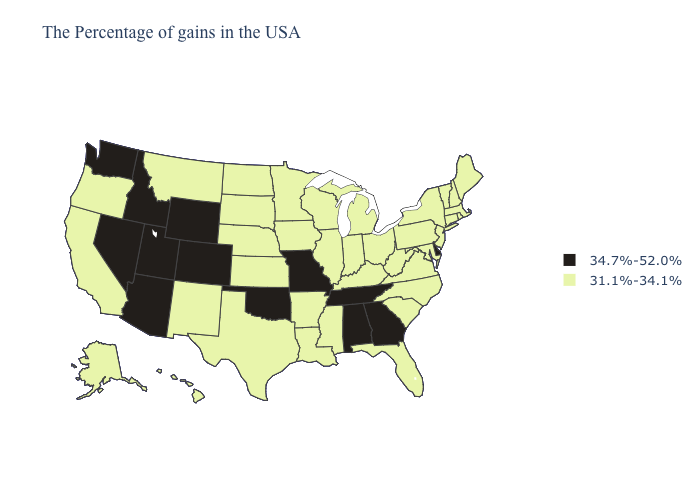What is the lowest value in states that border South Carolina?
Quick response, please. 31.1%-34.1%. Which states have the lowest value in the USA?
Quick response, please. Maine, Massachusetts, Rhode Island, New Hampshire, Vermont, Connecticut, New York, New Jersey, Maryland, Pennsylvania, Virginia, North Carolina, South Carolina, West Virginia, Ohio, Florida, Michigan, Kentucky, Indiana, Wisconsin, Illinois, Mississippi, Louisiana, Arkansas, Minnesota, Iowa, Kansas, Nebraska, Texas, South Dakota, North Dakota, New Mexico, Montana, California, Oregon, Alaska, Hawaii. Name the states that have a value in the range 34.7%-52.0%?
Concise answer only. Delaware, Georgia, Alabama, Tennessee, Missouri, Oklahoma, Wyoming, Colorado, Utah, Arizona, Idaho, Nevada, Washington. Does Nevada have the highest value in the USA?
Quick response, please. Yes. What is the highest value in states that border Ohio?
Give a very brief answer. 31.1%-34.1%. Name the states that have a value in the range 31.1%-34.1%?
Concise answer only. Maine, Massachusetts, Rhode Island, New Hampshire, Vermont, Connecticut, New York, New Jersey, Maryland, Pennsylvania, Virginia, North Carolina, South Carolina, West Virginia, Ohio, Florida, Michigan, Kentucky, Indiana, Wisconsin, Illinois, Mississippi, Louisiana, Arkansas, Minnesota, Iowa, Kansas, Nebraska, Texas, South Dakota, North Dakota, New Mexico, Montana, California, Oregon, Alaska, Hawaii. What is the value of Missouri?
Concise answer only. 34.7%-52.0%. Does Maryland have the same value as Rhode Island?
Concise answer only. Yes. What is the lowest value in states that border South Dakota?
Short answer required. 31.1%-34.1%. What is the lowest value in states that border Arkansas?
Concise answer only. 31.1%-34.1%. Among the states that border North Carolina , does Georgia have the lowest value?
Answer briefly. No. What is the value of Louisiana?
Concise answer only. 31.1%-34.1%. What is the highest value in the USA?
Short answer required. 34.7%-52.0%. Does Wyoming have the lowest value in the USA?
Concise answer only. No. Which states have the lowest value in the USA?
Short answer required. Maine, Massachusetts, Rhode Island, New Hampshire, Vermont, Connecticut, New York, New Jersey, Maryland, Pennsylvania, Virginia, North Carolina, South Carolina, West Virginia, Ohio, Florida, Michigan, Kentucky, Indiana, Wisconsin, Illinois, Mississippi, Louisiana, Arkansas, Minnesota, Iowa, Kansas, Nebraska, Texas, South Dakota, North Dakota, New Mexico, Montana, California, Oregon, Alaska, Hawaii. 